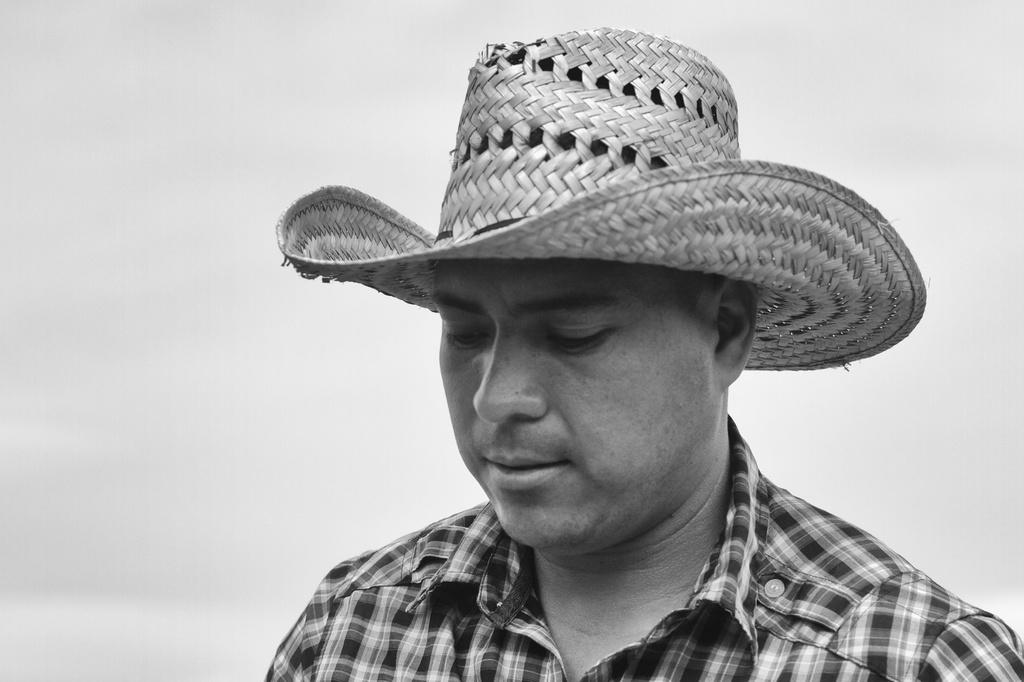Who is present in the image? There is a man in the image. What is the man wearing on his upper body? The man is wearing a checked shirt. What type of headwear is the man wearing? The man is wearing a hat. What is the man's gaze directed towards? The man is looking down. What is the color of the background in the image? The background in the image is white. Can you see the man's knee in the image? There is no indication of the man's knee in the image, as it only shows him from the waist up. 